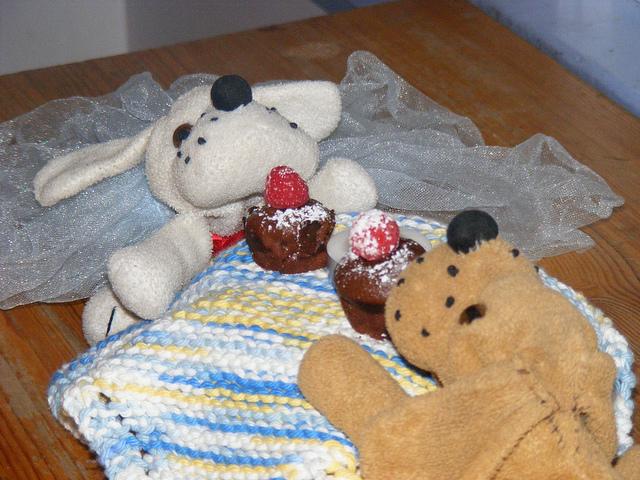Where are the cupcakes?
Be succinct. Blanket. Are the cupcakes sweet?
Keep it brief. Yes. Are the stuffed animals eating strawberry cupcakes?
Write a very short answer. Yes. 